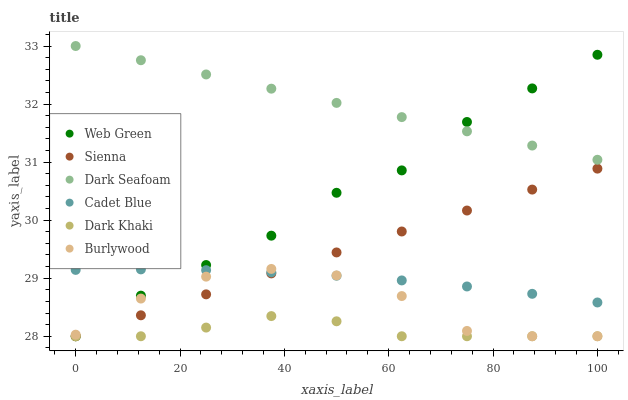Does Dark Khaki have the minimum area under the curve?
Answer yes or no. Yes. Does Dark Seafoam have the maximum area under the curve?
Answer yes or no. Yes. Does Cadet Blue have the minimum area under the curve?
Answer yes or no. No. Does Cadet Blue have the maximum area under the curve?
Answer yes or no. No. Is Dark Seafoam the smoothest?
Answer yes or no. Yes. Is Burlywood the roughest?
Answer yes or no. Yes. Is Cadet Blue the smoothest?
Answer yes or no. No. Is Cadet Blue the roughest?
Answer yes or no. No. Does Dark Khaki have the lowest value?
Answer yes or no. Yes. Does Cadet Blue have the lowest value?
Answer yes or no. No. Does Dark Seafoam have the highest value?
Answer yes or no. Yes. Does Cadet Blue have the highest value?
Answer yes or no. No. Is Burlywood less than Dark Seafoam?
Answer yes or no. Yes. Is Cadet Blue greater than Dark Khaki?
Answer yes or no. Yes. Does Web Green intersect Burlywood?
Answer yes or no. Yes. Is Web Green less than Burlywood?
Answer yes or no. No. Is Web Green greater than Burlywood?
Answer yes or no. No. Does Burlywood intersect Dark Seafoam?
Answer yes or no. No. 